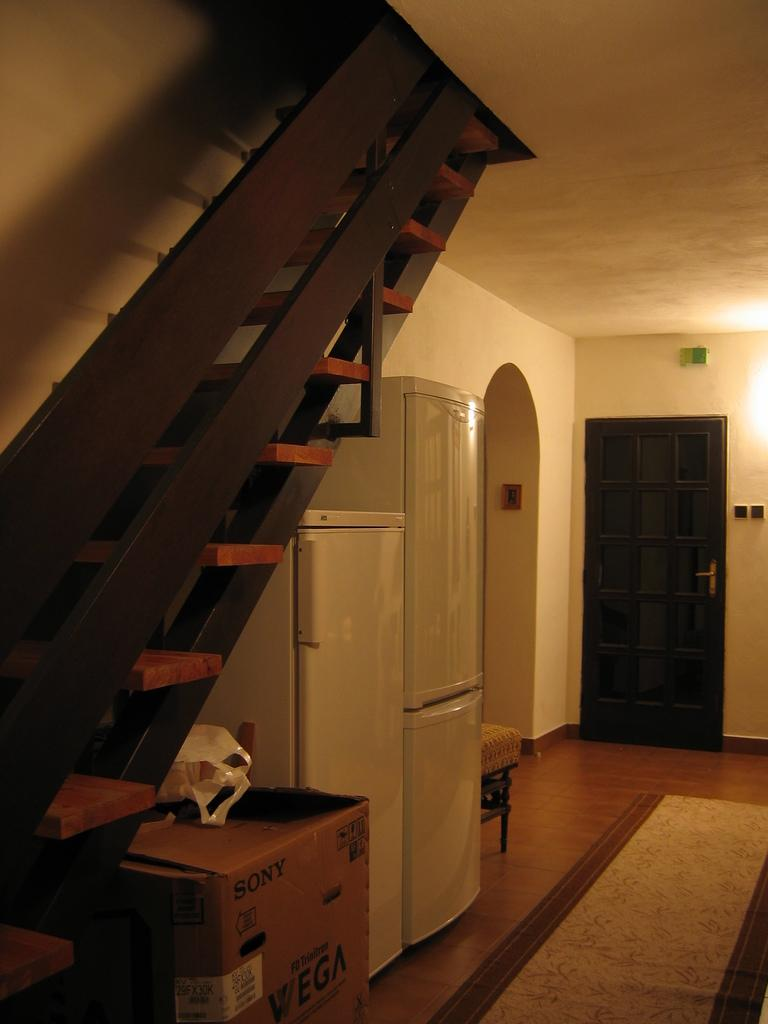What can be seen on the left side of the image? There is a staircase on the left side of the image. What is located below the staircase? A refrigerator is located below the staircase. What is on the right side of the image? There is a door on the right side of the image. What is above the door? A light is above the door. What type of flooring is present in the image? There is carpet on the floor. What is the best route to take in the fight depicted in the image? There is no fight depicted in the image, so it is not possible to determine the best route to take. 